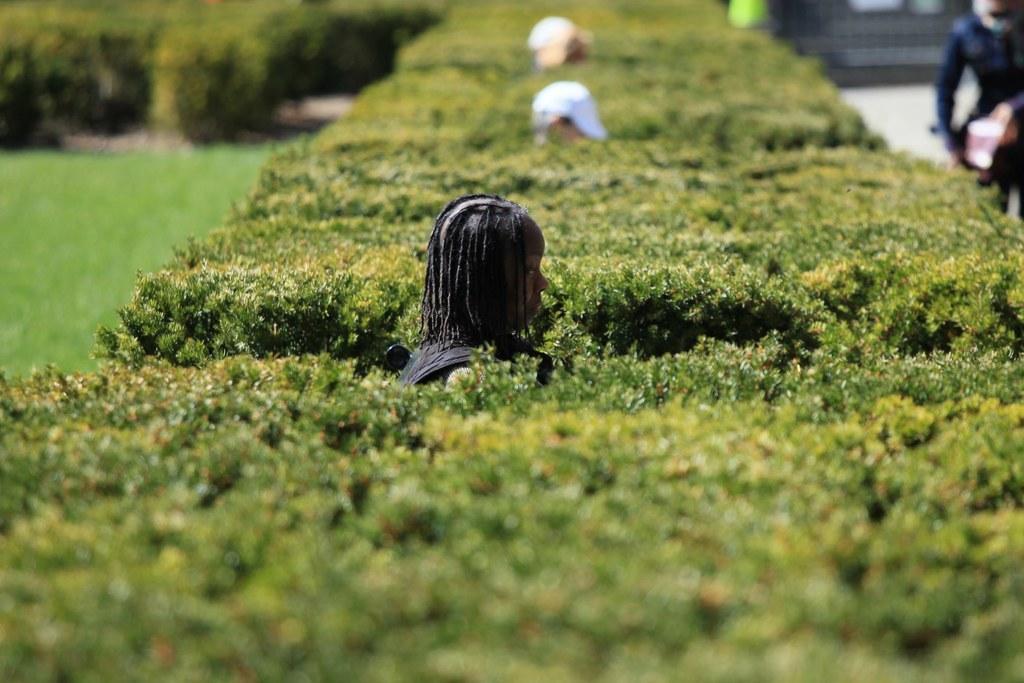Could you give a brief overview of what you see in this image? This picture shows few people standing and a man wore cap on his head and we see trees and grass on the ground. We see a human standing on the side. 